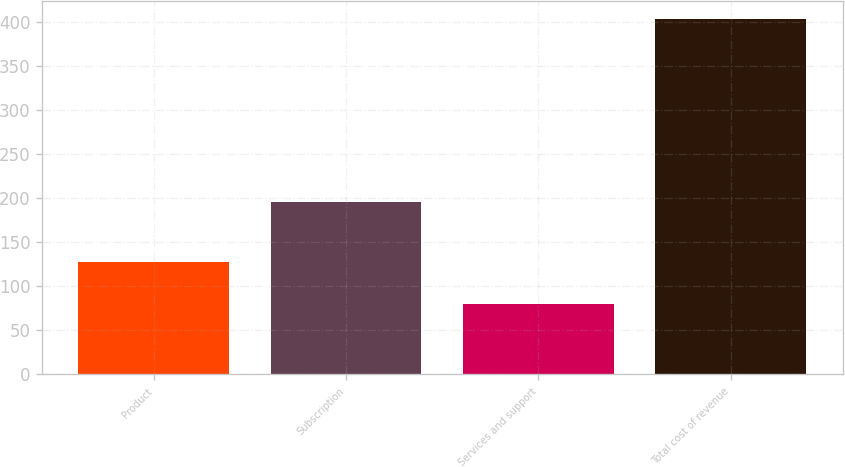Convert chart. <chart><loc_0><loc_0><loc_500><loc_500><bar_chart><fcel>Product<fcel>Subscription<fcel>Services and support<fcel>Total cost of revenue<nl><fcel>127.5<fcel>195.6<fcel>80.4<fcel>403.5<nl></chart> 